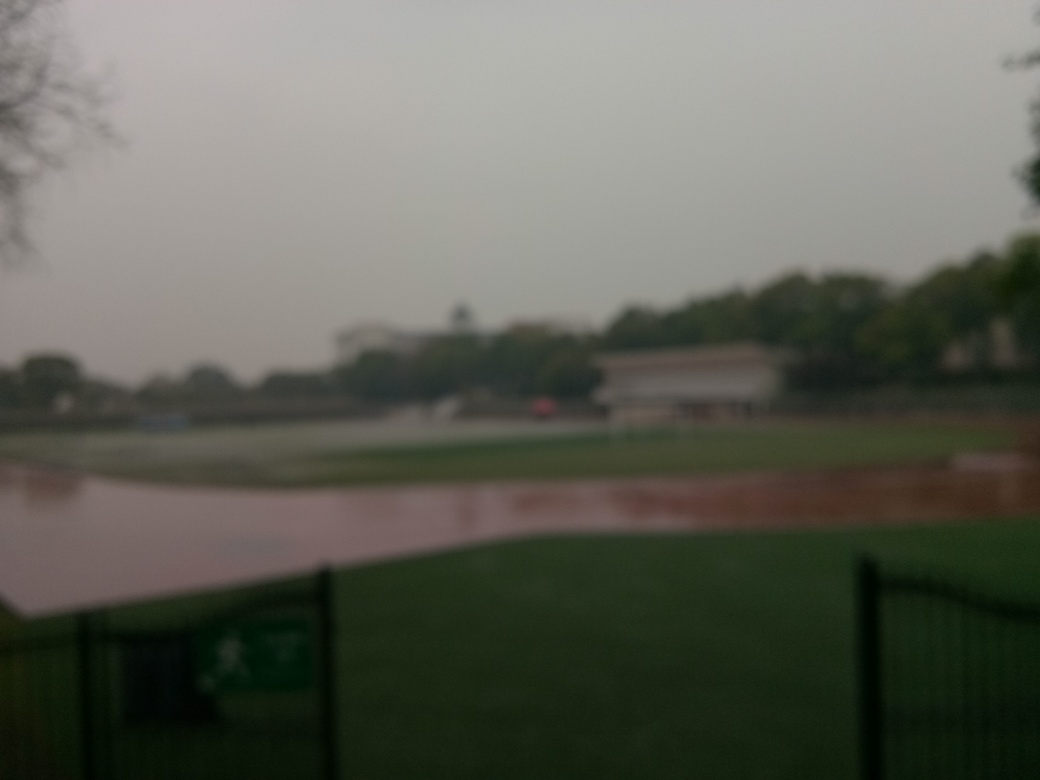Are there any quality issues with this image? Yes, the image appears to be out of focus and lacks sharpness, which affects the visibility of details. Additionally, there seems to be a haze or mist, which could be due to environmental conditions or a smudged lens, leading to reduced contrast and clarity. The overall exposure also appears to be uneven, contributing to the quality issues observed. 